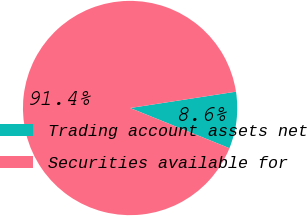<chart> <loc_0><loc_0><loc_500><loc_500><pie_chart><fcel>Trading account assets net<fcel>Securities available for<nl><fcel>8.56%<fcel>91.44%<nl></chart> 